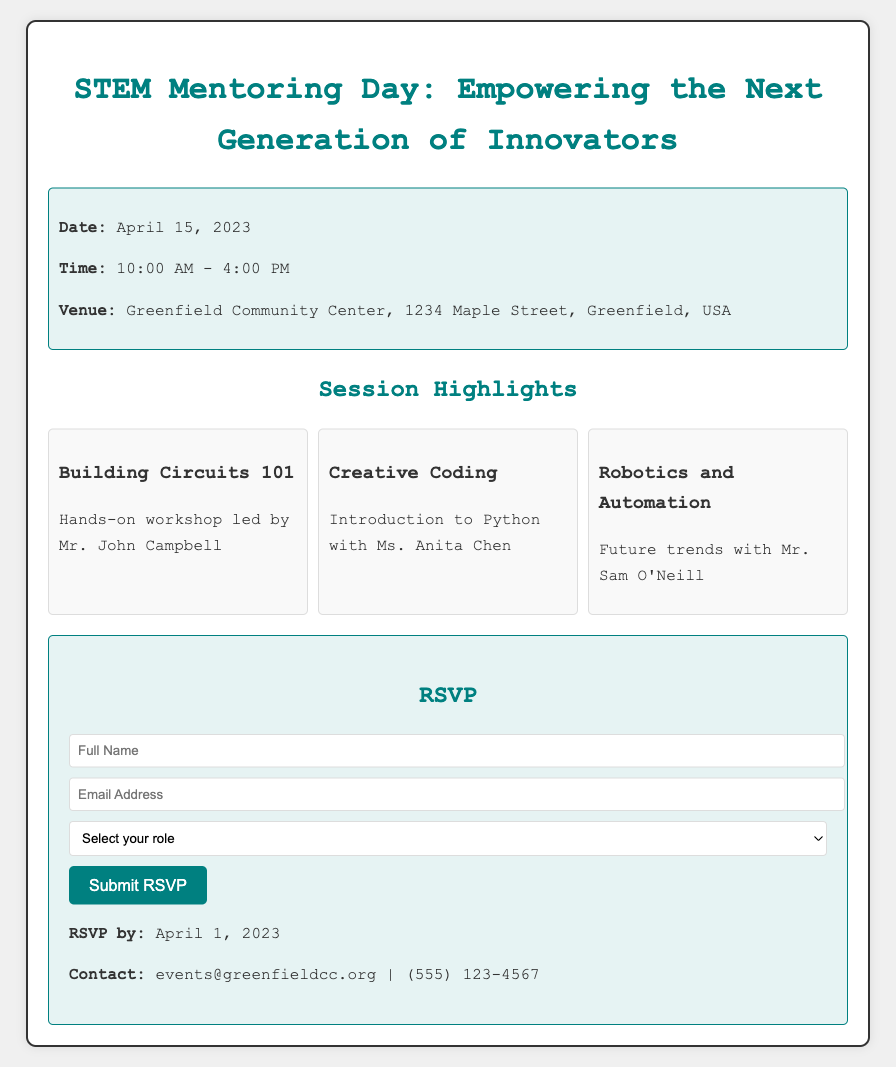What is the date of the event? The date of the event is mentioned in the "event-details" section of the document.
Answer: April 15, 2023 Who is the speaker for the "Building Circuits 101" session? The speaker's name is listed under the session title in the "sessions" section of the document.
Answer: Mr. John Campbell What time does the event start? The starting time of the event is provided in the "event-details" section.
Answer: 10:00 AM How many sessions are highlighted in the document? The number of sessions can be counted from the "sessions" section of the document.
Answer: Three What is the role selection option for the RSVP? The role selection options are found in the RSVP form of the document.
Answer: Student, Mentor, Professional What is the contact email provided? The contact email is listed in the RSVP section of the document.
Answer: events@greenfieldcc.org What type of activity is "Creative Coding"? This activity is categorized in the "sessions" section as a workshop.
Answer: Introduction to Python What should attendees do by April 1, 2023? The document clearly states what action needs to be taken by this date in the RSVP section.
Answer: RSVP 